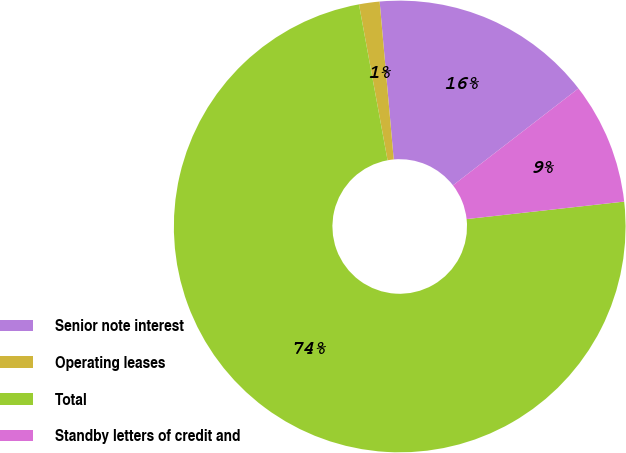<chart> <loc_0><loc_0><loc_500><loc_500><pie_chart><fcel>Senior note interest<fcel>Operating leases<fcel>Total<fcel>Standby letters of credit and<nl><fcel>15.95%<fcel>1.47%<fcel>73.87%<fcel>8.71%<nl></chart> 